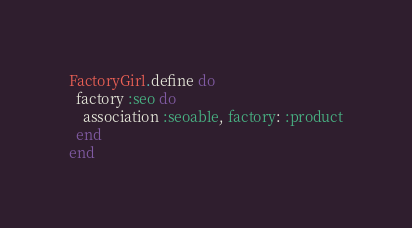Convert code to text. <code><loc_0><loc_0><loc_500><loc_500><_Ruby_>FactoryGirl.define do
  factory :seo do
    association :seoable, factory: :product
  end
end
</code> 